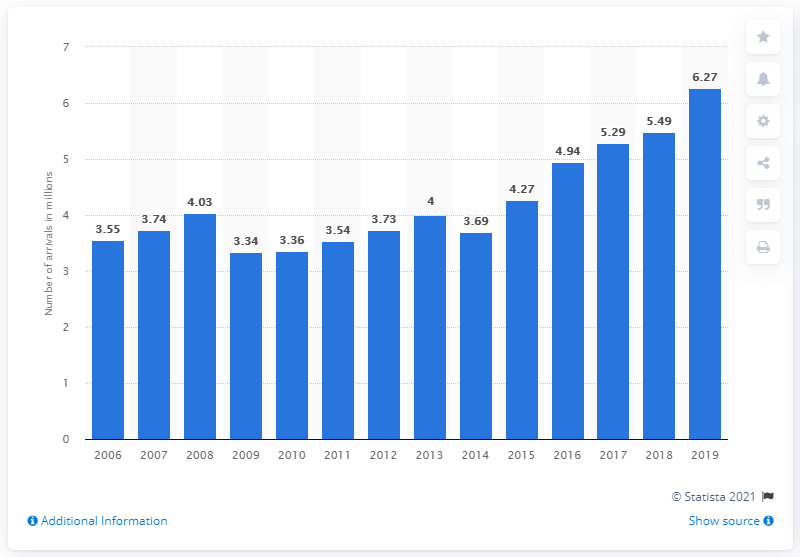Mention a couple of crucial points in this snapshot. The number of tourist arrivals in short-stay accommodation in Slovakia has been increasing since 2014. In 2019, a total of 6.27 million foreign and domestic tourists stayed in Slovakian accommodation establishments. 